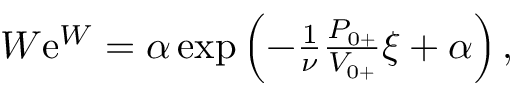<formula> <loc_0><loc_0><loc_500><loc_500>\begin{array} { r } { W e ^ { W } = \alpha \exp \left ( - \frac { 1 } { \nu } \frac { { P } _ { 0 + } } { { V } _ { 0 + } } \xi + \alpha \right ) , } \end{array}</formula> 